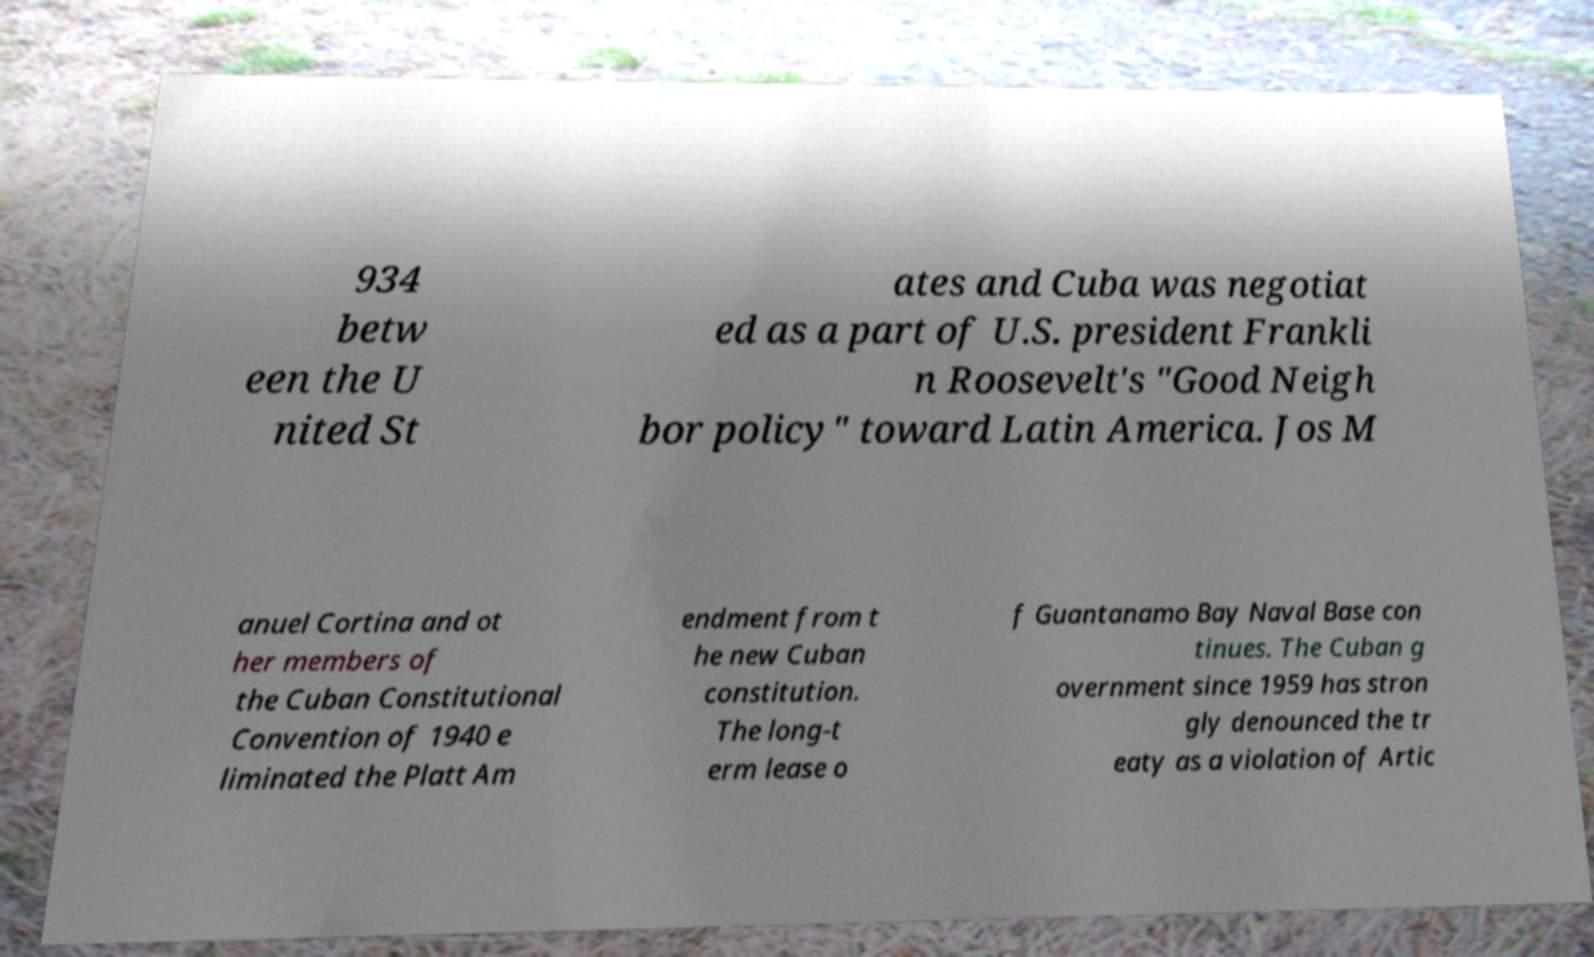Please identify and transcribe the text found in this image. 934 betw een the U nited St ates and Cuba was negotiat ed as a part of U.S. president Frankli n Roosevelt's "Good Neigh bor policy" toward Latin America. Jos M anuel Cortina and ot her members of the Cuban Constitutional Convention of 1940 e liminated the Platt Am endment from t he new Cuban constitution. The long-t erm lease o f Guantanamo Bay Naval Base con tinues. The Cuban g overnment since 1959 has stron gly denounced the tr eaty as a violation of Artic 